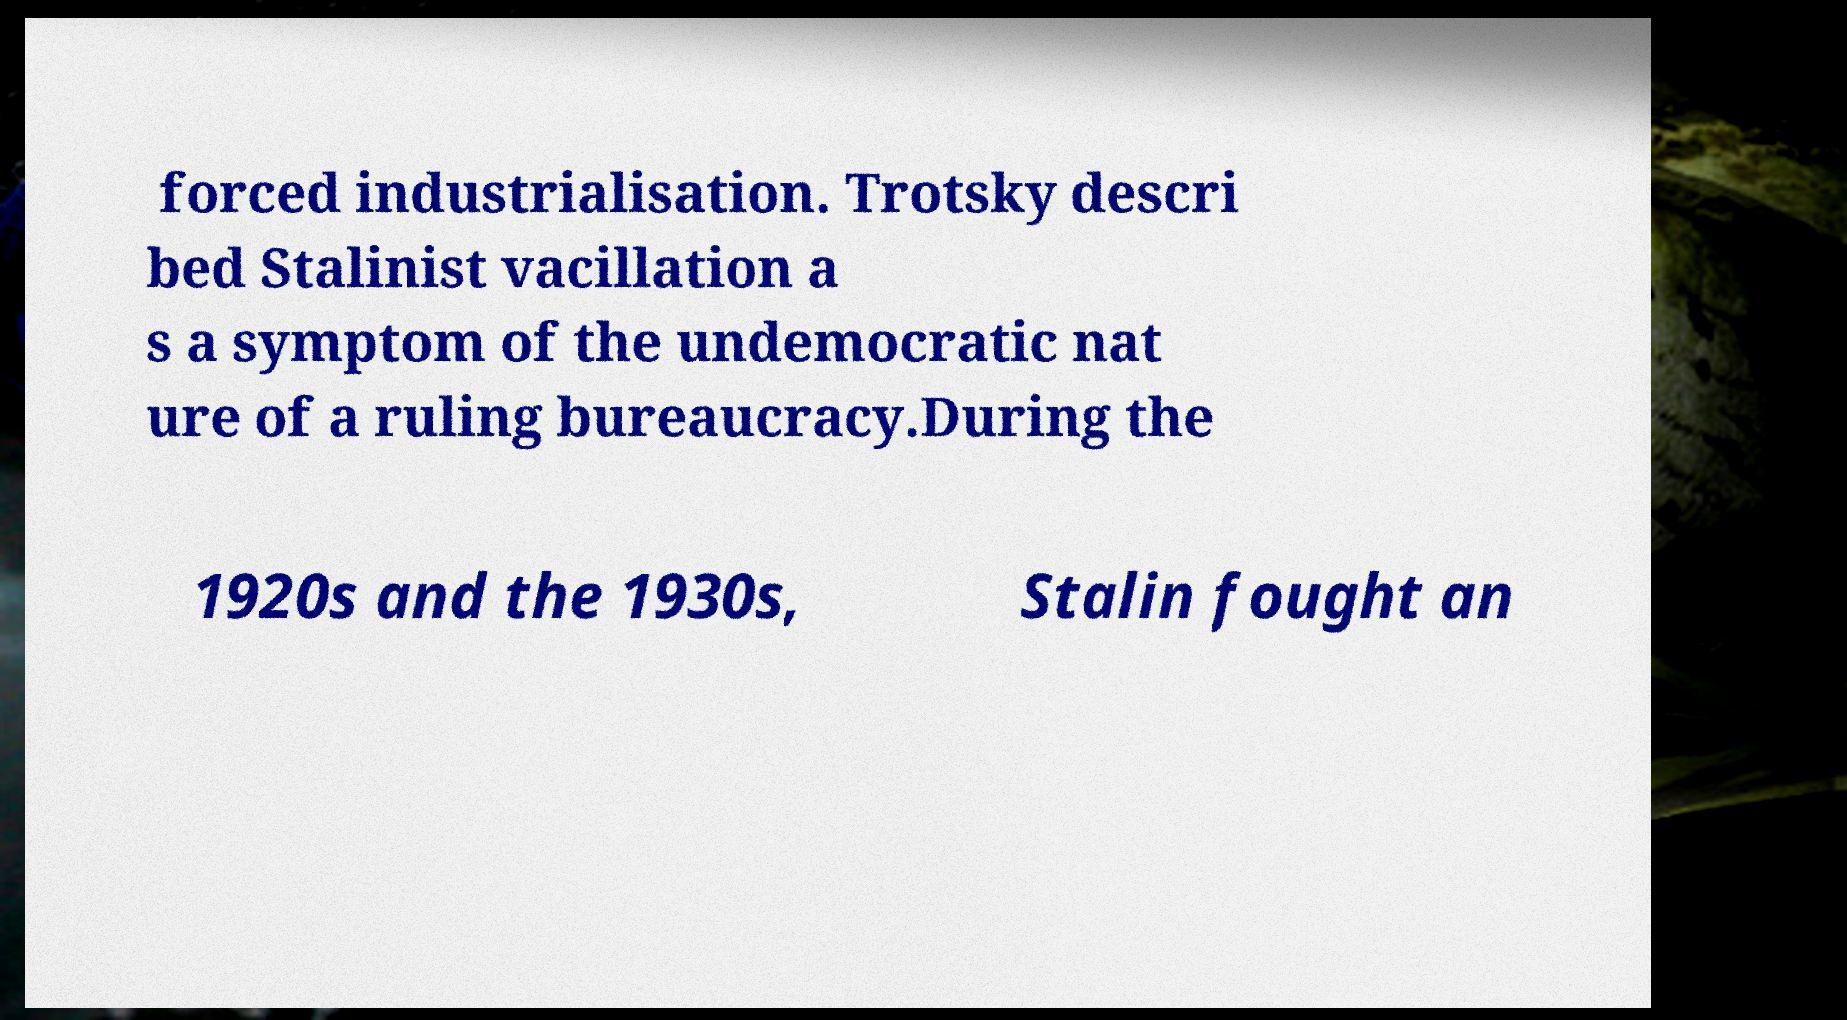What messages or text are displayed in this image? I need them in a readable, typed format. forced industrialisation. Trotsky descri bed Stalinist vacillation a s a symptom of the undemocratic nat ure of a ruling bureaucracy.During the 1920s and the 1930s, Stalin fought an 